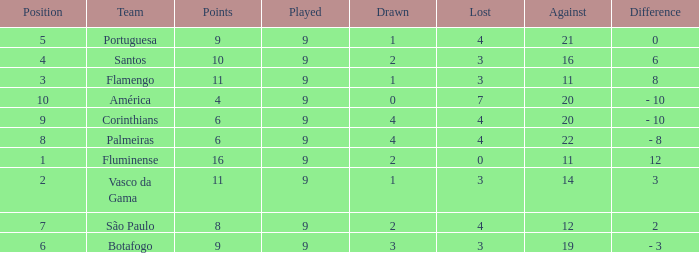Which Points is the highest one that has a Position of 1, and a Lost smaller than 0? None. Give me the full table as a dictionary. {'header': ['Position', 'Team', 'Points', 'Played', 'Drawn', 'Lost', 'Against', 'Difference'], 'rows': [['5', 'Portuguesa', '9', '9', '1', '4', '21', '0'], ['4', 'Santos', '10', '9', '2', '3', '16', '6'], ['3', 'Flamengo', '11', '9', '1', '3', '11', '8'], ['10', 'América', '4', '9', '0', '7', '20', '- 10'], ['9', 'Corinthians', '6', '9', '4', '4', '20', '- 10'], ['8', 'Palmeiras', '6', '9', '4', '4', '22', '- 8'], ['1', 'Fluminense', '16', '9', '2', '0', '11', '12'], ['2', 'Vasco da Gama', '11', '9', '1', '3', '14', '3'], ['7', 'São Paulo', '8', '9', '2', '4', '12', '2'], ['6', 'Botafogo', '9', '9', '3', '3', '19', '- 3']]} 